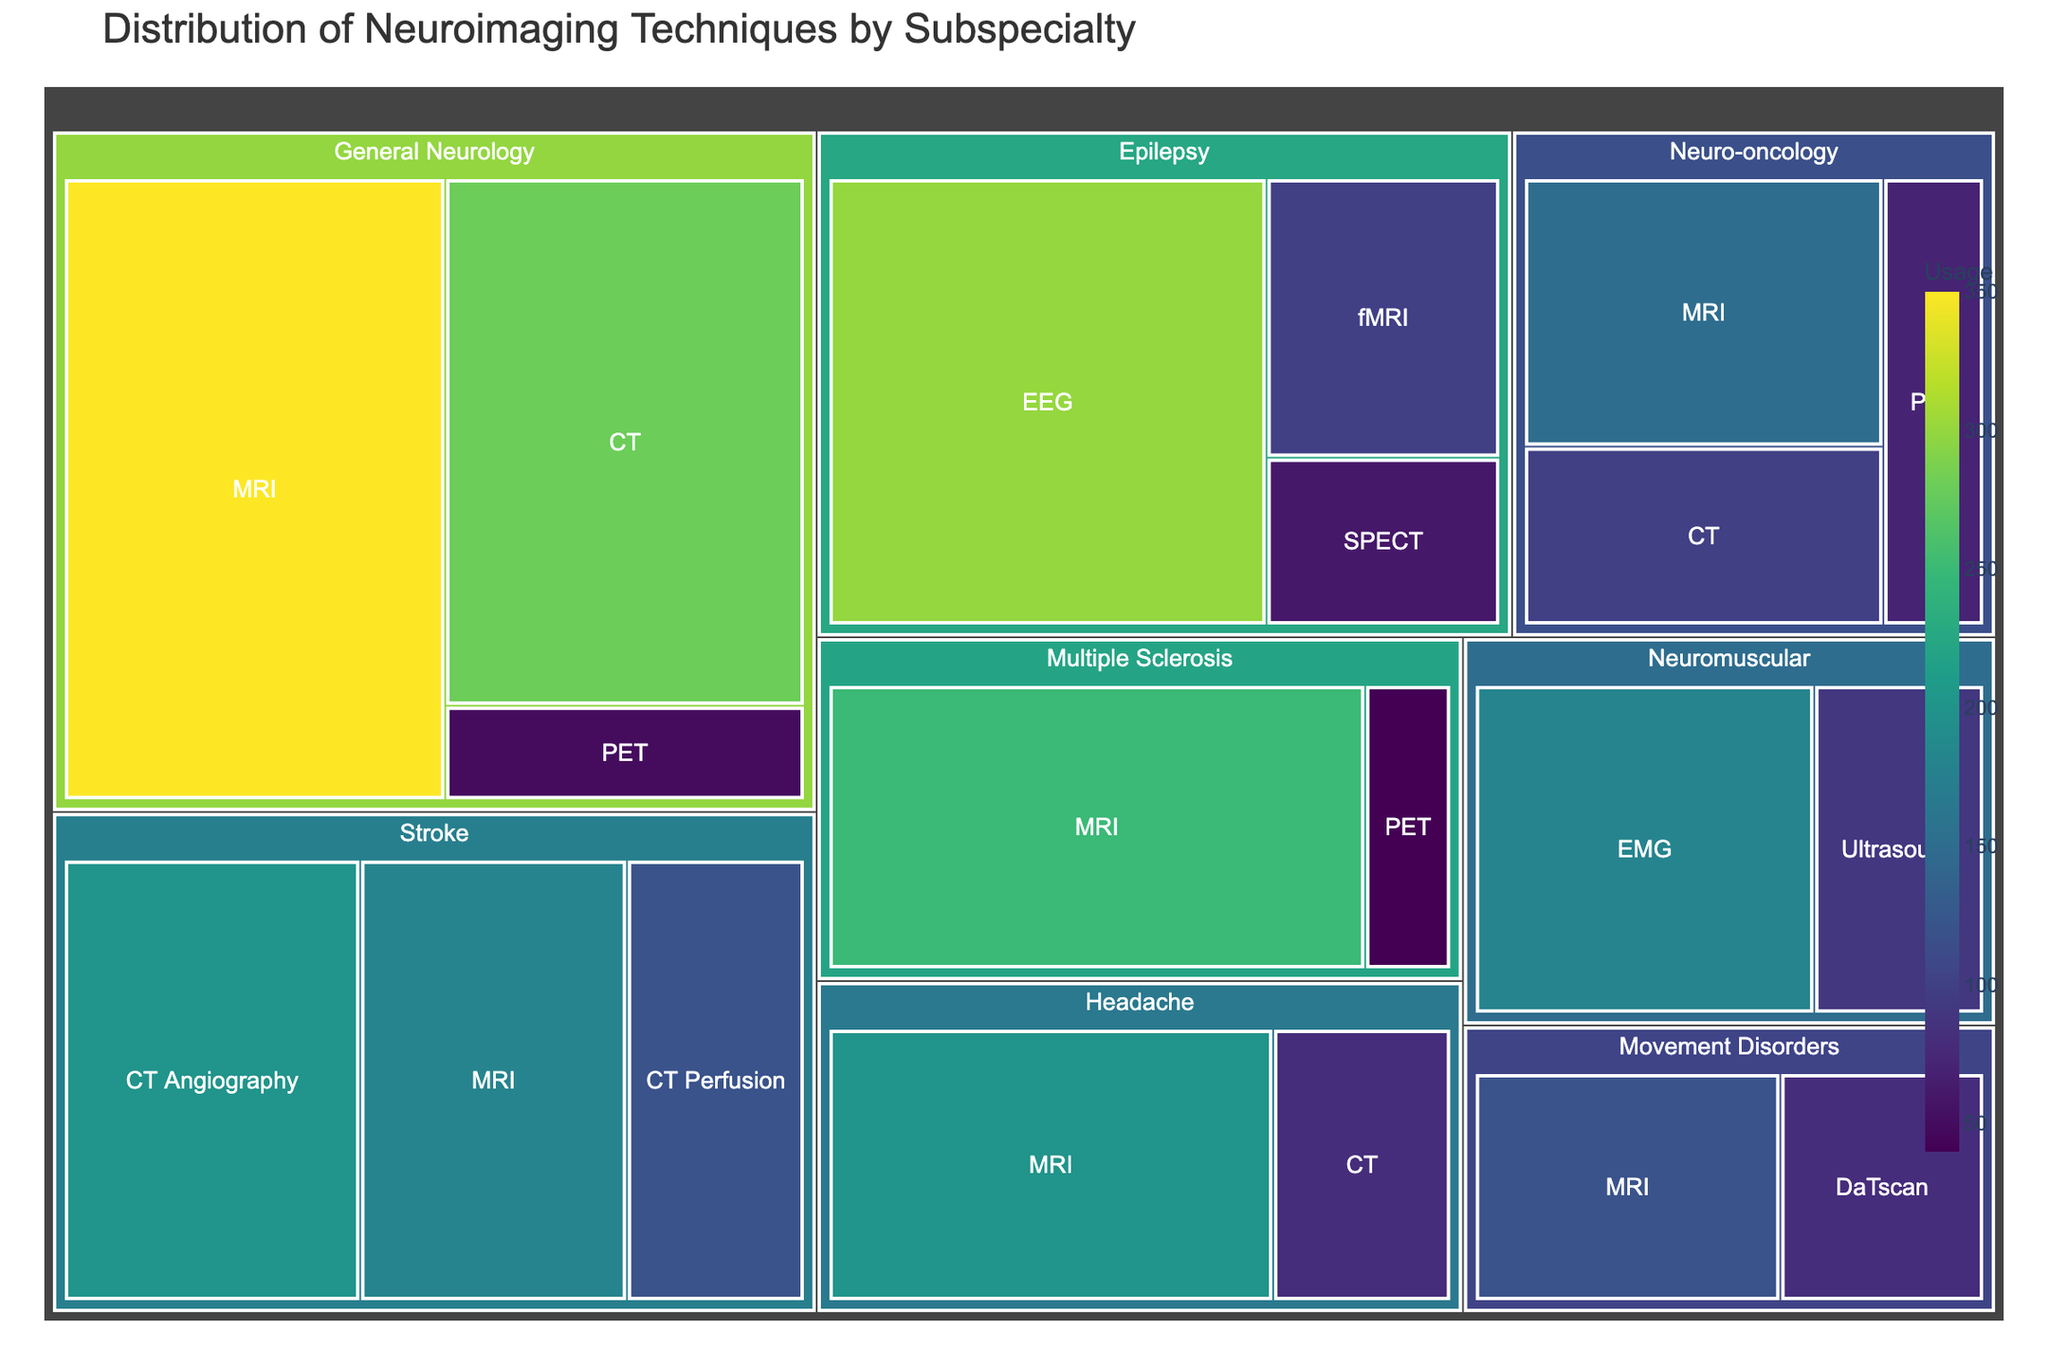What are the top three subspecialties with the highest usage of MRI? To determine the top three subspecialties with the highest usage of MRI, look at the sections labeled 'MRI' under each subspecialty and compare their usage values. The top three are General Neurology (350), Multiple Sclerosis (250), and Headache (200).
Answer: General Neurology, Multiple Sclerosis, Headache Which modality has the highest total usage across all subspecialties? To find the modality with the highest total usage, sum the usage values of each modality across all subspecialties. MRI has the highest total usage: General Neurology (350), Stroke (180), Epilepsy (100), Multiple Sclerosis (250), Movement Disorders (120), Neuro-oncology (150), Headache (200). The total is 1350.
Answer: MRI How does the usage of CT in Headache compare to its usage in General Neurology? Look at the CT usage values for both subspecialties. Headache has a CT usage of 80, while General Neurology has a CT usage of 280. By comparing them, General Neurology uses CT more frequently than Headache.
Answer: General Neurology uses CT more What is the sum of all imaging modalities used in Stroke subspecialty? Add up the usage values of all modalities within the Stroke subspecialty: CT Angiography (200), MRI (180), CT Perfusion (120). The sum is 500.
Answer: 500 What are the least used imaging modalities and their associated subspecialties? Identify the imaging modalities with the smallest usage values from the treemap. The least used modalities are PET in Multiple Sclerosis (40) and PET in General Neurology (50).
Answer: PET in Multiple Sclerosis and General Neurology Which subspecialty relies most heavily on PET scans? Compare the usage of PET scans across all subspecialties. General Neurology has a PET usage of 50, Multiple Sclerosis has 40, and Neuro-oncology has 70. Neuro-oncology has the highest PET usage.
Answer: Neuro-oncology What is the average usage of all modalities within the Epilepsy subspecialty? Calculate the average usage by summing the modality usages under Epilepsy (EEG 300, fMRI 100, SPECT 60) and dividing by the number of modalities (3). The average usage is (300 + 100 + 60) / 3 = 153.33.
Answer: 153.33 Is the usage of MRI higher in Movement Disorders or Multiple Sclerosis? Compare the MRI usage values between Movement Disorders (120) and Multiple Sclerosis (250). Multiple Sclerosis has a higher MRI usage.
Answer: Multiple Sclerosis Which subspecialty has the highest total usage of all imaging modalities combined? Sum the usage values of all imaging modalities within each subspecialty and compare them. General Neurology (680), Stroke (500), Epilepsy (460), Multiple Sclerosis (290), Movement Disorders (200), Neuromuscular (270), Neuro-oncology (320), Headache (280). General Neurology has the highest total usage.
Answer: General Neurology 